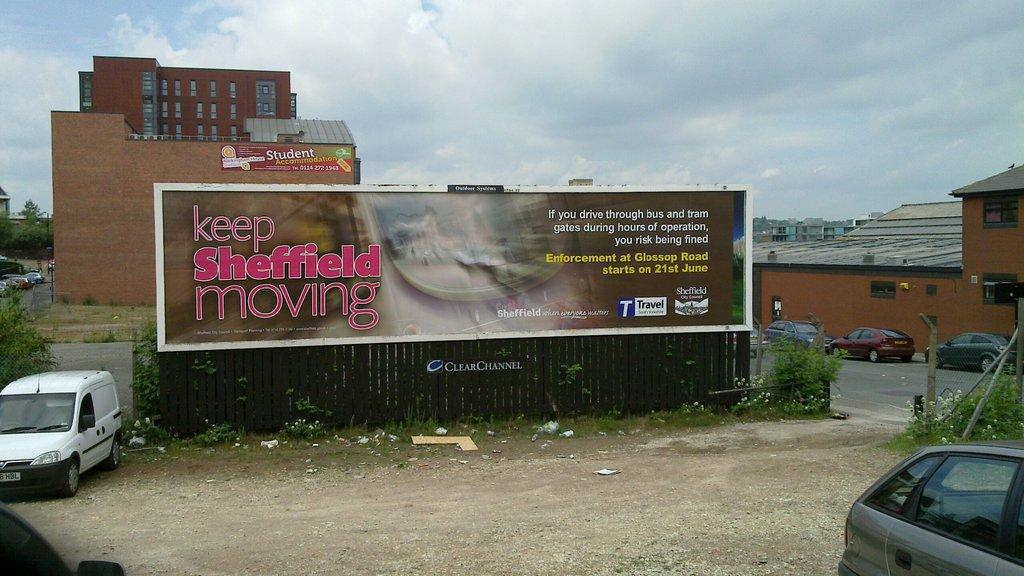Provide a one-sentence caption for the provided image. A billboard in a messy city says to keep Sheffield moving. 